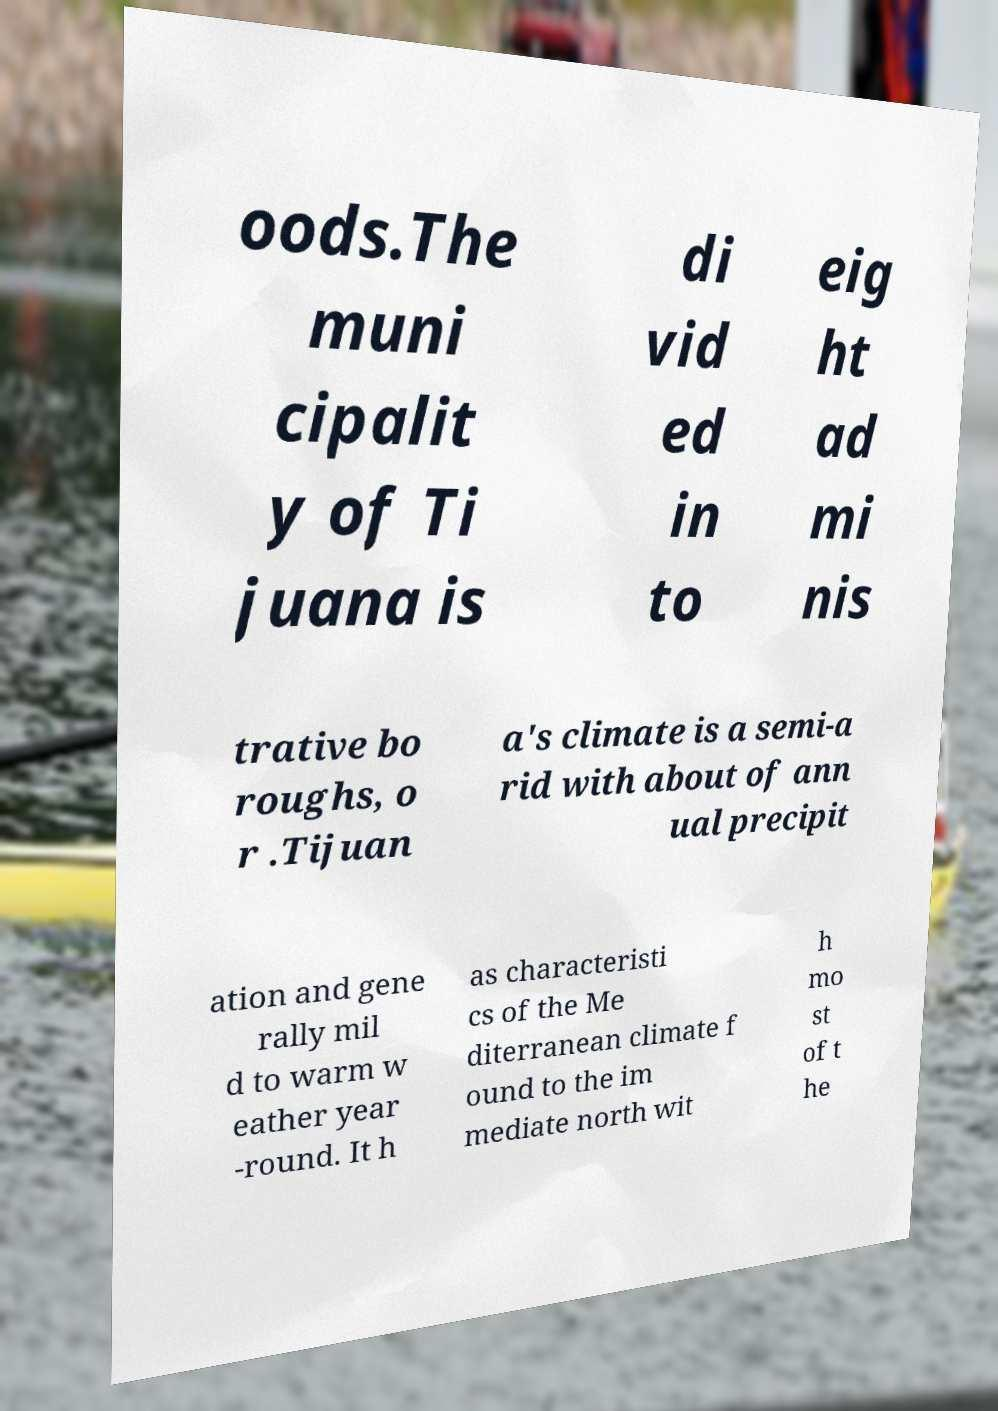Can you accurately transcribe the text from the provided image for me? oods.The muni cipalit y of Ti juana is di vid ed in to eig ht ad mi nis trative bo roughs, o r .Tijuan a's climate is a semi-a rid with about of ann ual precipit ation and gene rally mil d to warm w eather year -round. It h as characteristi cs of the Me diterranean climate f ound to the im mediate north wit h mo st of t he 